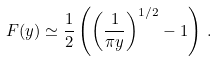<formula> <loc_0><loc_0><loc_500><loc_500>F ( y ) \simeq \frac { 1 } { 2 } \left ( \left ( \frac { 1 } { \pi y } \right ) ^ { 1 / 2 } - 1 \right ) \, .</formula> 